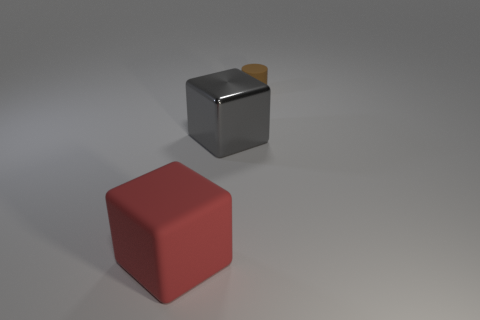There is a large red thing that is the same shape as the gray thing; what is it made of?
Offer a very short reply. Rubber. How many things are either large blocks to the right of the rubber block or tiny cylinders?
Your answer should be compact. 2. There is a tiny object that is the same material as the large red thing; what is its shape?
Offer a very short reply. Cylinder. What number of big yellow objects have the same shape as the gray thing?
Ensure brevity in your answer.  0. What is the tiny cylinder made of?
Your answer should be very brief. Rubber. There is a metal cube; does it have the same color as the rubber thing that is on the right side of the rubber cube?
Provide a succinct answer. No. What number of balls are red objects or matte objects?
Your response must be concise. 0. There is a rubber object behind the large red block; what is its color?
Your response must be concise. Brown. What number of other things are the same size as the gray thing?
Provide a short and direct response. 1. Is the shape of the object that is left of the metallic object the same as the object that is behind the gray metallic block?
Give a very brief answer. No. 